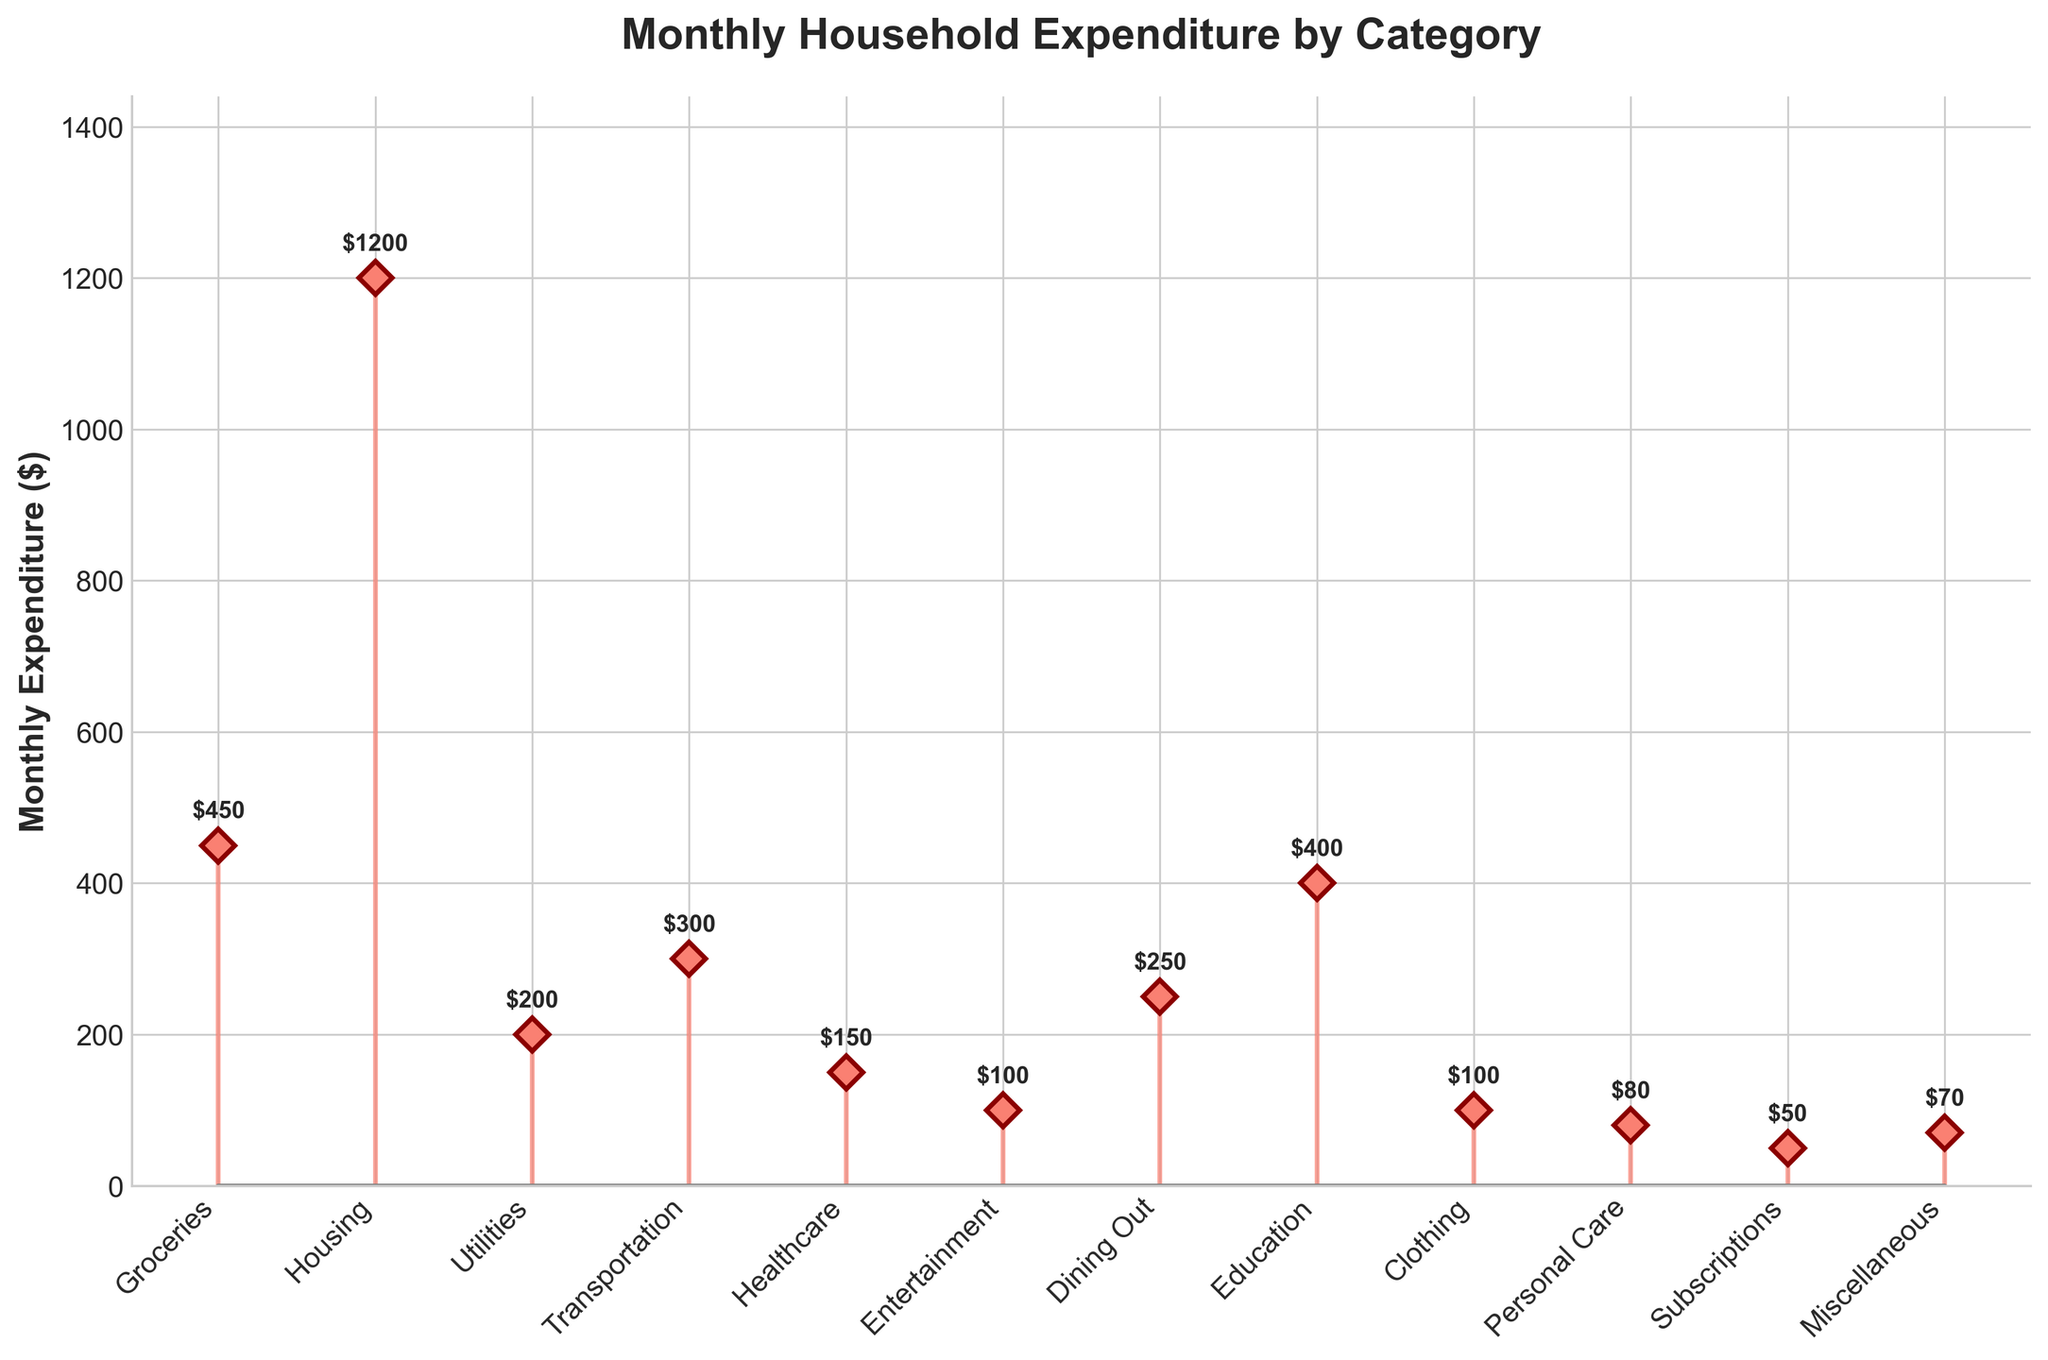What is the title of the figure? The title is located at the top of the figure, usually in a larger and bold font to make it prominent.
Answer: Monthly Household Expenditure by Category What is the label of the y-axis in the figure? The y-axis label is placed vertically and describes the measurement unit displayed on the y-axis.
Answer: Monthly Expenditure ($) How many categories are displayed in the plot? Count the number of distinct categories listed along the x-axis.
Answer: 12 Which category has the highest monthly expenditure? Look for the stem (line) that reaches the highest point on the y-axis.
Answer: Housing How much more is spent on Groceries compared to Entertainment? Identify the expenditures for Groceries and Entertainment and calculate their difference: $450 (Groceries) - $100 (Entertainment) = $350.
Answer: $350 What is the combined expenditure for Dining Out and Personal Care? Add the amounts for Dining Out ($250) and Personal Care ($80): $250 + $80 = $330.
Answer: $330 Does Transportation have a higher expenditure than Education? Compare the stem heights for Transportation ($300) and Education ($400). Transportation's height is lower, indicating a smaller expenditure.
Answer: No What is the average expenditure on Healthcare, Clothing, and Miscellaneous? (1) Sum the expenditures: $150 (Healthcare) + $100 (Clothing) + $70 (Miscellaneous) = $320. (2) Divide the sum by the number of categories (3): $320 / 3 ≈ $106.67.
Answer: ~$106.67 Which category has the lowest monthly expenditure? Look for the stem closest to the x-axis.
Answer: Subscriptions By how much does the expenditure on Housing exceed the expenditure on Utilities? Subtract Utilities' expenditure from Housing's: $1200 (Housing) - $200 (Utilities) = $1000.
Answer: $1000 